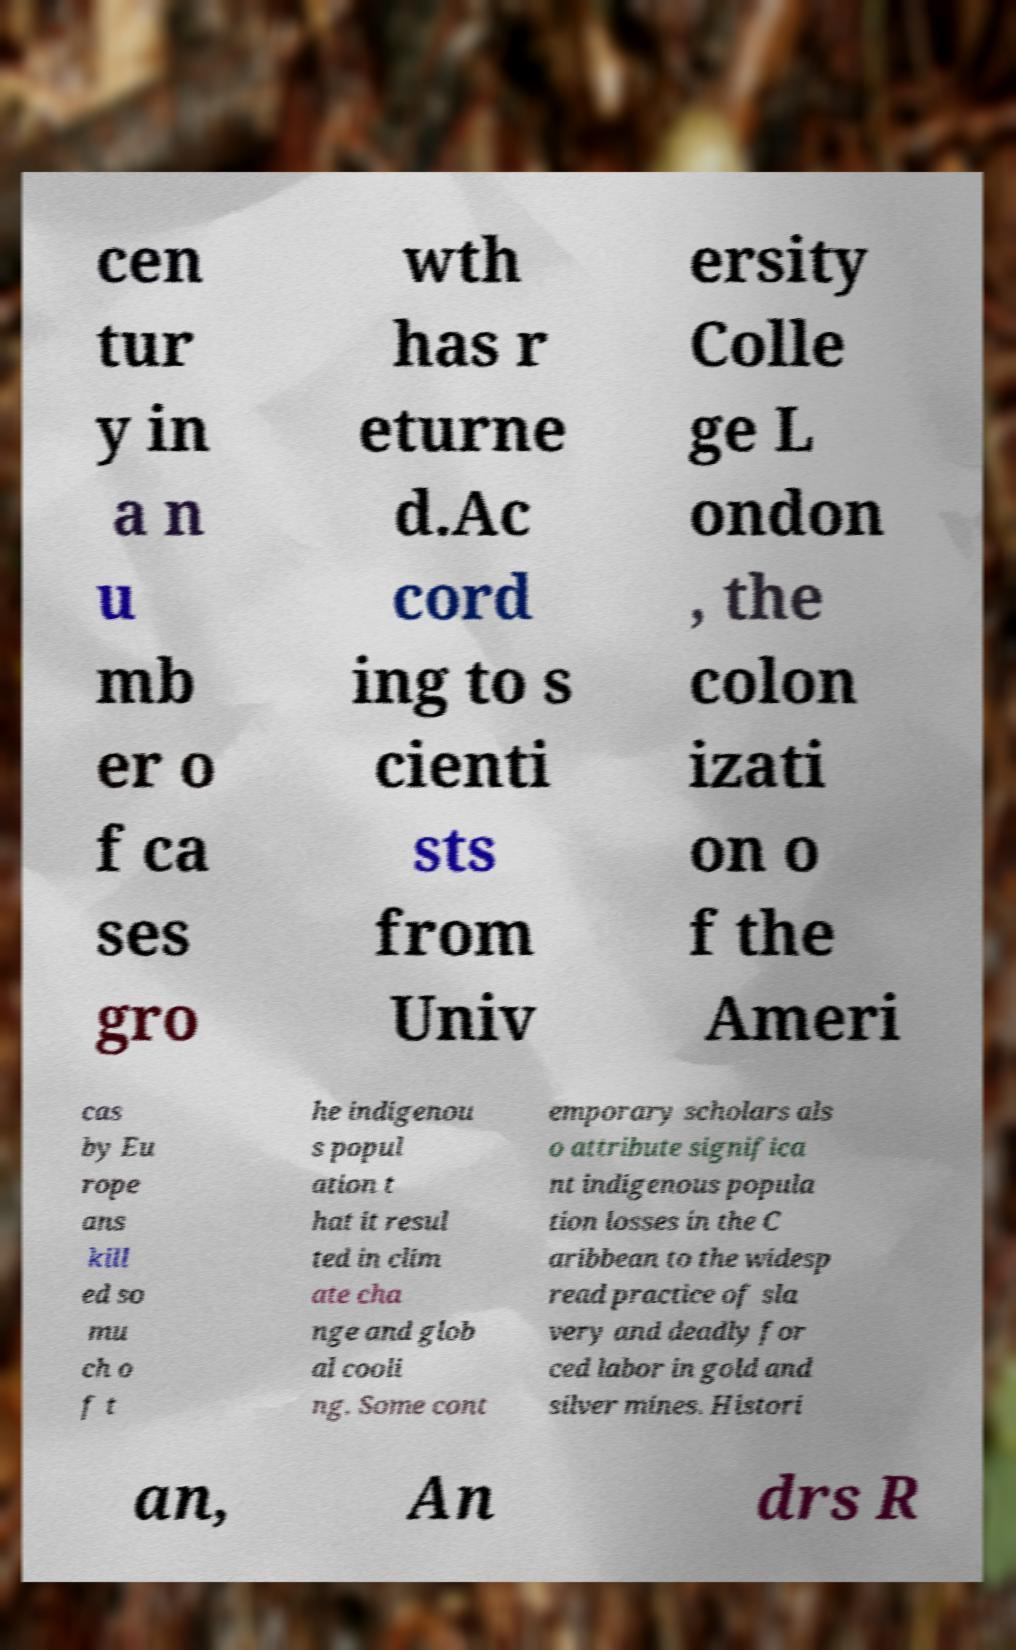Can you accurately transcribe the text from the provided image for me? cen tur y in a n u mb er o f ca ses gro wth has r eturne d.Ac cord ing to s cienti sts from Univ ersity Colle ge L ondon , the colon izati on o f the Ameri cas by Eu rope ans kill ed so mu ch o f t he indigenou s popul ation t hat it resul ted in clim ate cha nge and glob al cooli ng. Some cont emporary scholars als o attribute significa nt indigenous popula tion losses in the C aribbean to the widesp read practice of sla very and deadly for ced labor in gold and silver mines. Histori an, An drs R 